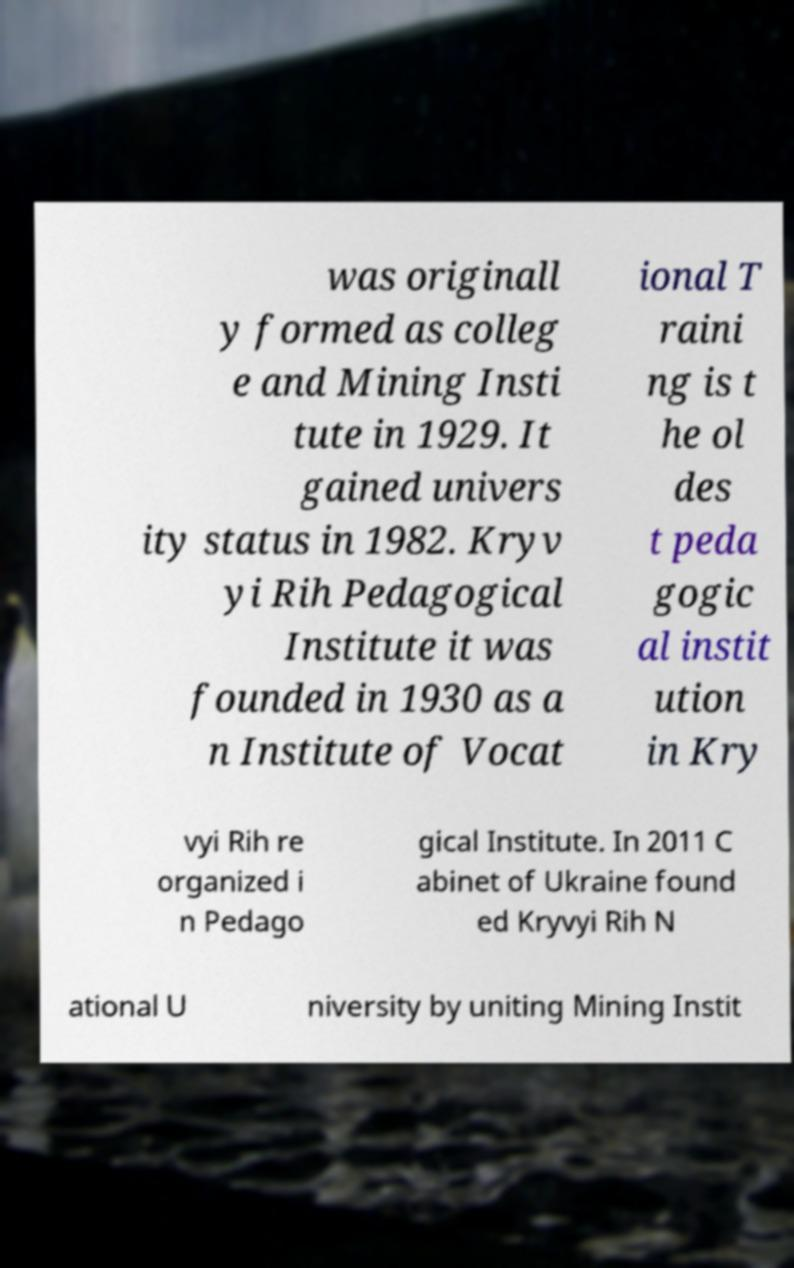Could you extract and type out the text from this image? was originall y formed as colleg e and Mining Insti tute in 1929. It gained univers ity status in 1982. Kryv yi Rih Pedagogical Institute it was founded in 1930 as a n Institute of Vocat ional T raini ng is t he ol des t peda gogic al instit ution in Kry vyi Rih re organized i n Pedago gical Institute. In 2011 C abinet of Ukraine found ed Kryvyi Rih N ational U niversity by uniting Mining Instit 